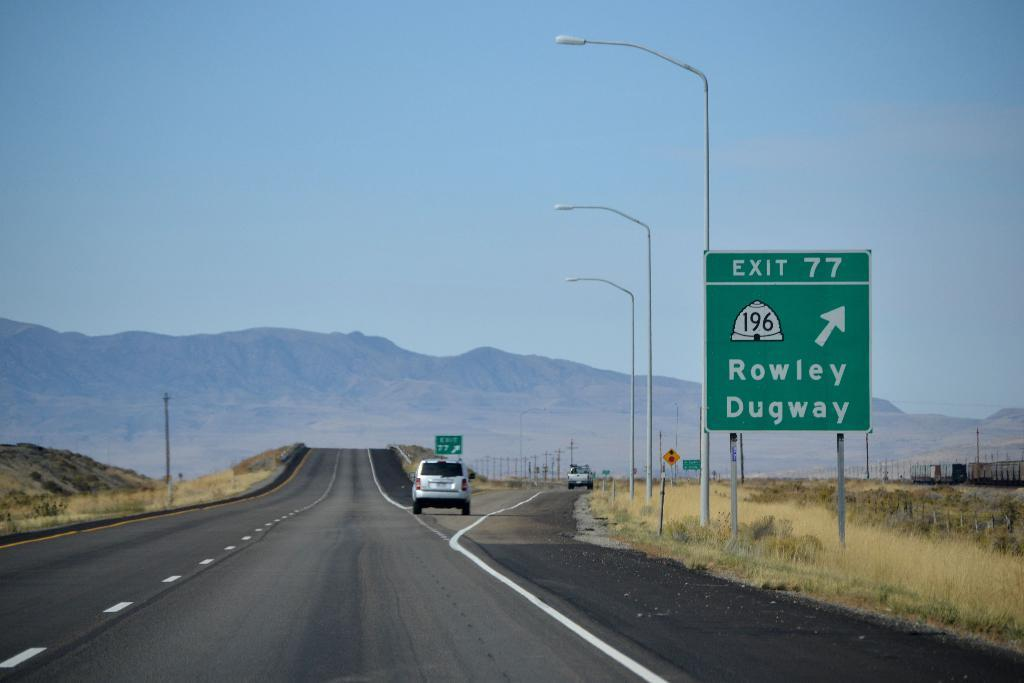<image>
Describe the image concisely. Car exiting a route named Rowley Dugway on Exit 77. 